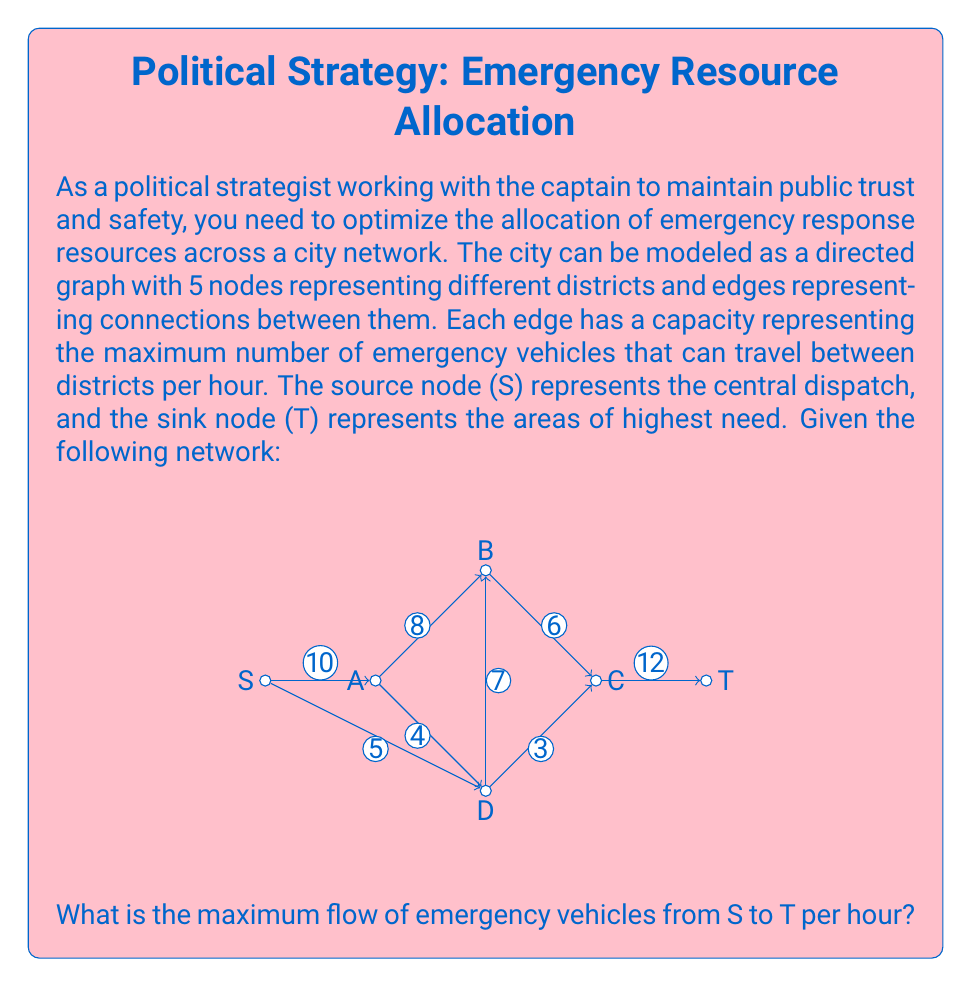Can you answer this question? To solve this problem, we can use the Ford-Fulkerson algorithm to find the maximum flow in the network. The algorithm works as follows:

1. Initialize the flow on all edges to 0.
2. Find an augmenting path from S to T (a path with unused capacity on all edges).
3. Augment the flow along this path by the minimum capacity of any edge on the path.
4. Repeat steps 2-3 until no augmenting path can be found.

Let's apply the algorithm step by step:

Iteration 1:
Path: S -> A -> B -> C -> T
Min capacity: min(10, 8, 6, 12) = 6
Flow after augmentation: 6

Iteration 2:
Path: S -> D -> C -> T
Min capacity: min(5, 3, 12-6) = 3
Flow after augmentation: 6 + 3 = 9

Iteration 3:
Path: S -> D -> B -> C -> T
Min capacity: min(5-3, 7, 6-6, 12-9) = 2
Flow after augmentation: 9 + 2 = 11

Iteration 4:
Path: S -> A -> D -> B -> C -> T
Min capacity: min(10-6, 4, 7-2, 6-6, 12-11) = 1
Flow after augmentation: 11 + 1 = 12

At this point, no more augmenting paths can be found, so the algorithm terminates.

The final flow configuration is:
- S -> A: 7
- S -> D: 5
- A -> B: 6
- A -> D: 1
- D -> B: 3
- D -> C: 3
- B -> C: 9
- C -> T: 12

The maximum flow from S to T is 12 emergency vehicles per hour.
Answer: 12 emergency vehicles per hour 